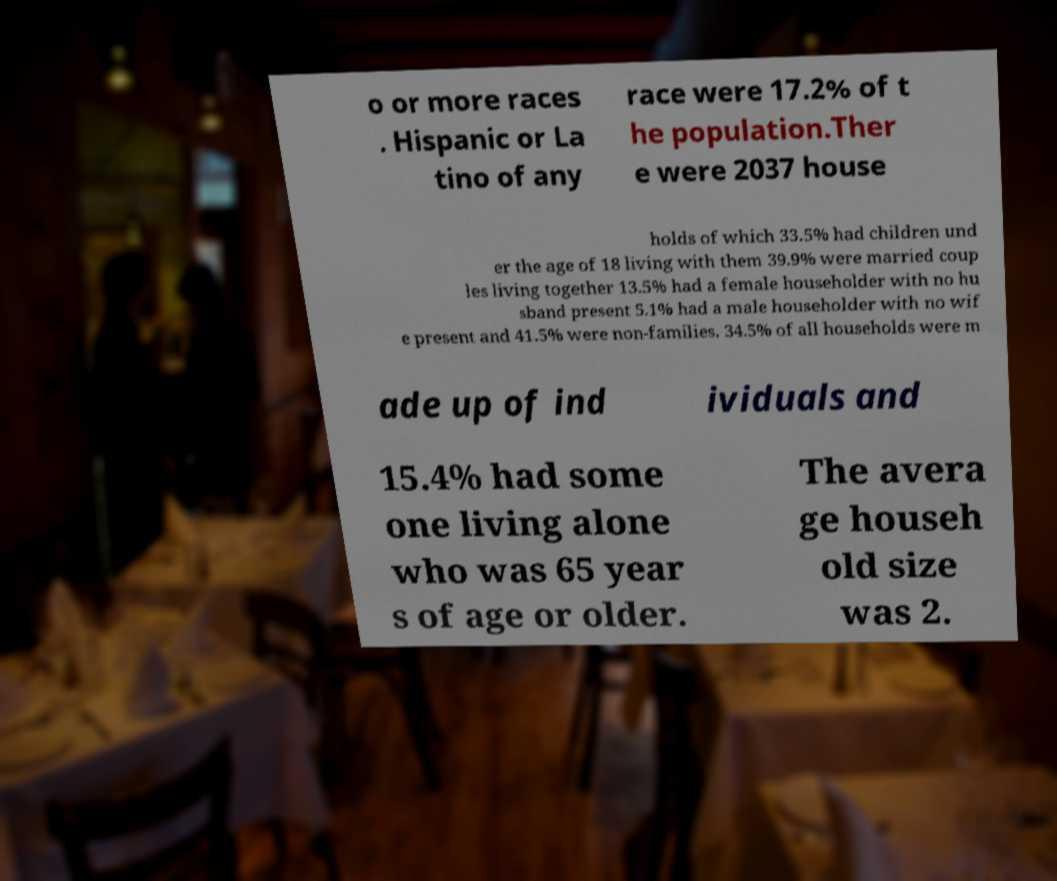Could you extract and type out the text from this image? o or more races . Hispanic or La tino of any race were 17.2% of t he population.Ther e were 2037 house holds of which 33.5% had children und er the age of 18 living with them 39.9% were married coup les living together 13.5% had a female householder with no hu sband present 5.1% had a male householder with no wif e present and 41.5% were non-families. 34.5% of all households were m ade up of ind ividuals and 15.4% had some one living alone who was 65 year s of age or older. The avera ge househ old size was 2. 